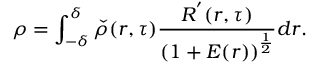<formula> <loc_0><loc_0><loc_500><loc_500>\rho = \int _ { - \delta } ^ { \delta } \check { \rho } ( r , \tau ) \frac { R ^ { ^ { \prime } } ( r , \tau ) } { \left ( 1 + E ( r ) \right ) ^ { \frac { 1 } { 2 } } } d r .</formula> 